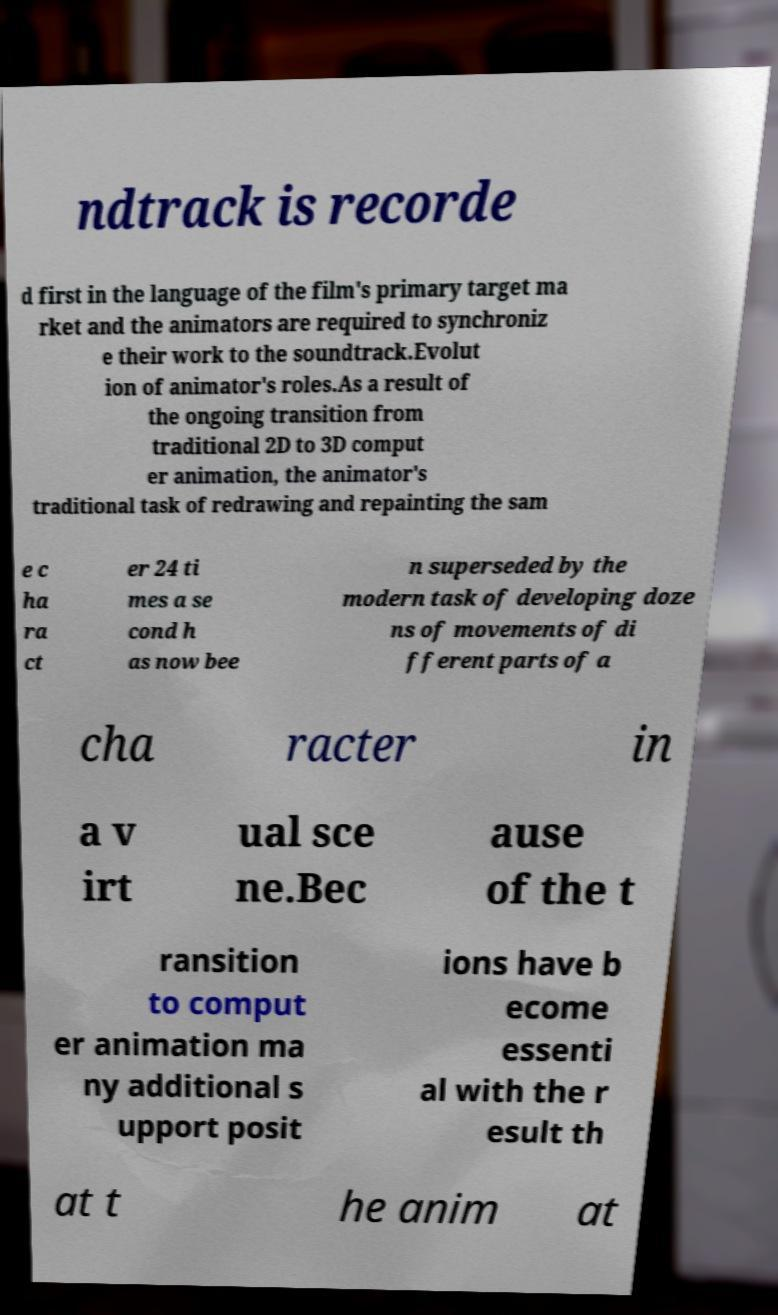Can you accurately transcribe the text from the provided image for me? ndtrack is recorde d first in the language of the film's primary target ma rket and the animators are required to synchroniz e their work to the soundtrack.Evolut ion of animator's roles.As a result of the ongoing transition from traditional 2D to 3D comput er animation, the animator's traditional task of redrawing and repainting the sam e c ha ra ct er 24 ti mes a se cond h as now bee n superseded by the modern task of developing doze ns of movements of di fferent parts of a cha racter in a v irt ual sce ne.Bec ause of the t ransition to comput er animation ma ny additional s upport posit ions have b ecome essenti al with the r esult th at t he anim at 